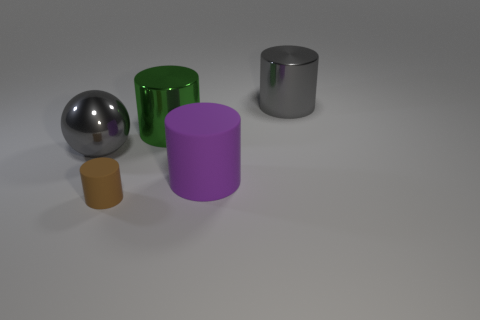Is there anything else that has the same size as the brown cylinder?
Provide a short and direct response. No. Are there any brown matte cylinders in front of the large gray metallic object that is left of the gray cylinder?
Ensure brevity in your answer.  Yes. What is the shape of the tiny thing?
Your response must be concise. Cylinder. What is the size of the gray object that is left of the gray metallic thing that is on the right side of the big rubber cylinder?
Offer a very short reply. Large. There is a shiny cylinder that is to the left of the large matte cylinder; what size is it?
Your response must be concise. Large. Is the number of large gray shiny balls that are in front of the small cylinder less than the number of purple matte cylinders that are to the left of the green thing?
Offer a terse response. No. What is the color of the small object?
Keep it short and to the point. Brown. Are there any shiny cylinders that have the same color as the big sphere?
Make the answer very short. Yes. What is the shape of the large green metallic object left of the gray shiny thing behind the large gray shiny thing that is left of the big gray cylinder?
Your answer should be very brief. Cylinder. There is a gray thing behind the large green cylinder; what is it made of?
Provide a succinct answer. Metal. 